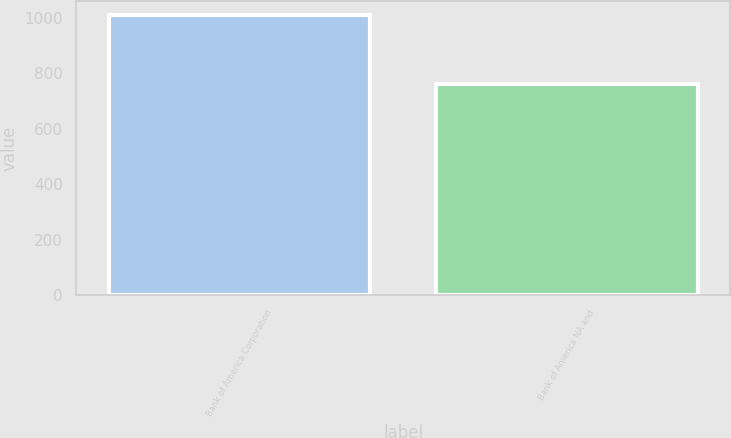Convert chart to OTSL. <chart><loc_0><loc_0><loc_500><loc_500><bar_chart><fcel>Bank of America Corporation<fcel>Bank of America NA and<nl><fcel>1011<fcel>762<nl></chart> 